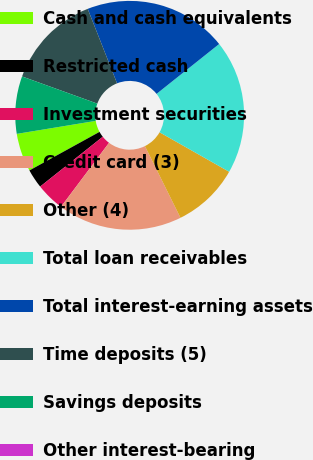Convert chart to OTSL. <chart><loc_0><loc_0><loc_500><loc_500><pie_chart><fcel>Cash and cash equivalents<fcel>Restricted cash<fcel>Investment securities<fcel>Credit card (3)<fcel>Other (4)<fcel>Total loan receivables<fcel>Total interest-earning assets<fcel>Time deposits (5)<fcel>Savings deposits<fcel>Other interest-bearing<nl><fcel>5.41%<fcel>2.7%<fcel>4.05%<fcel>17.57%<fcel>9.46%<fcel>18.92%<fcel>20.27%<fcel>13.51%<fcel>8.11%<fcel>0.0%<nl></chart> 